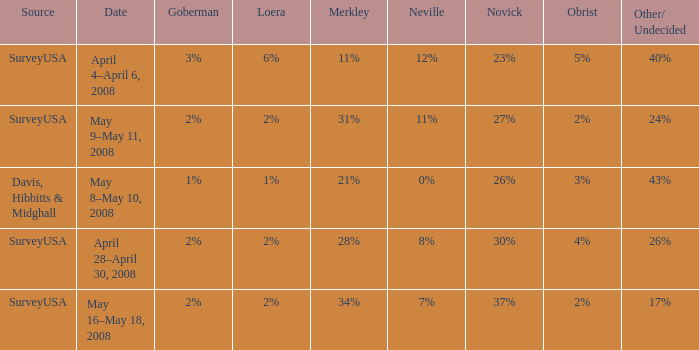Which Neville has a Novick of 23%? 12%. 